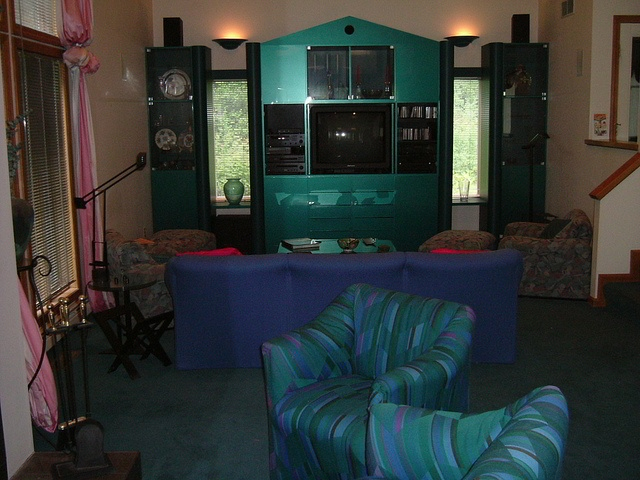Describe the objects in this image and their specific colors. I can see chair in maroon, black, blue, darkblue, and darkgreen tones, couch in maroon, black, navy, and blue tones, chair in maroon, teal, gray, and darkblue tones, couch in maroon, black, and navy tones, and tv in maroon, black, teal, gray, and darkgreen tones in this image. 